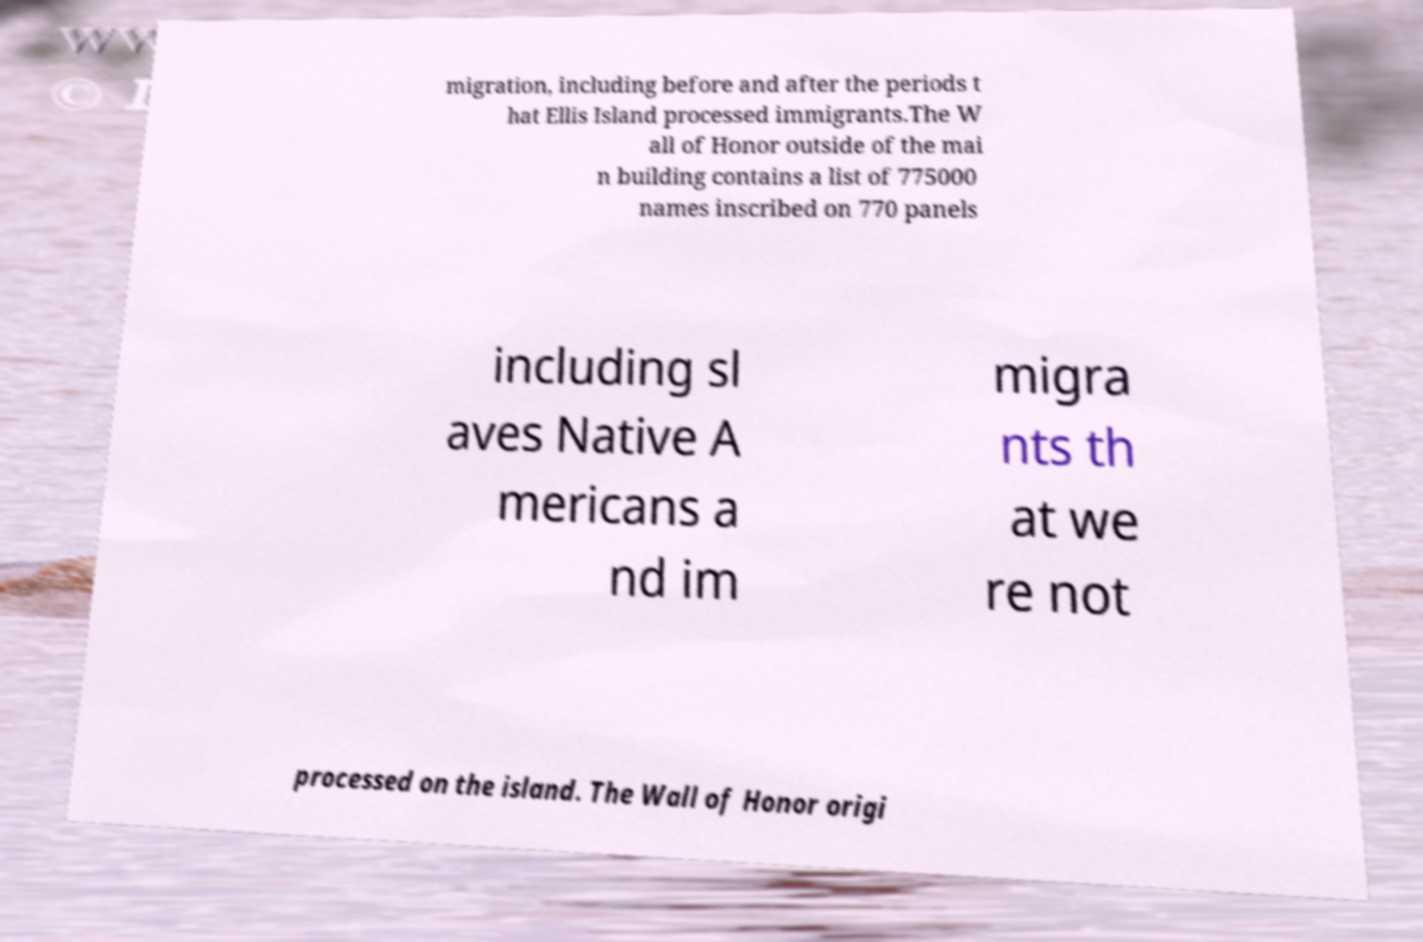Could you extract and type out the text from this image? migration, including before and after the periods t hat Ellis Island processed immigrants.The W all of Honor outside of the mai n building contains a list of 775000 names inscribed on 770 panels including sl aves Native A mericans a nd im migra nts th at we re not processed on the island. The Wall of Honor origi 